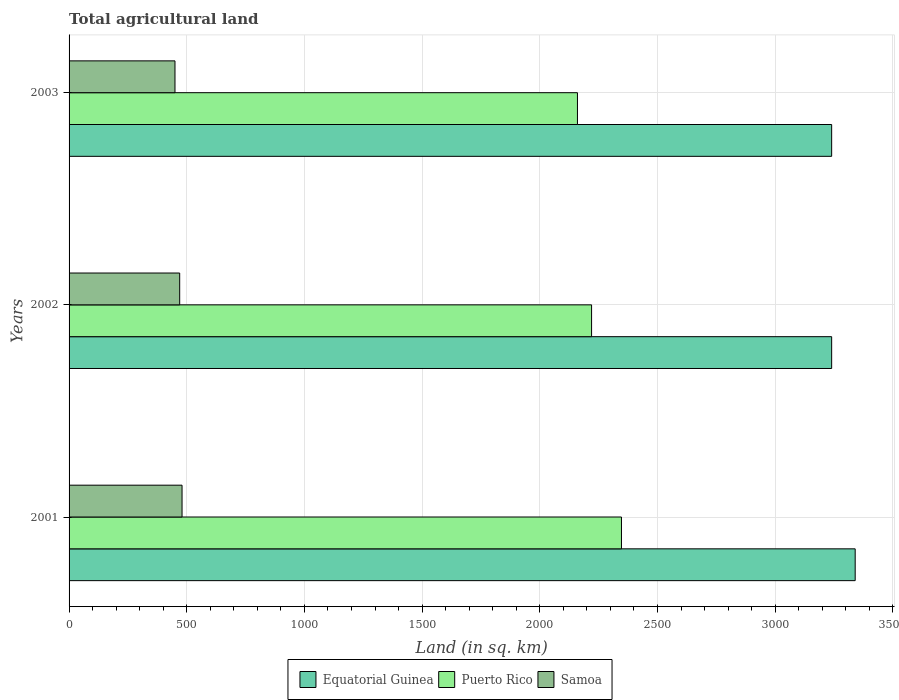How many different coloured bars are there?
Your response must be concise. 3. How many bars are there on the 1st tick from the bottom?
Your answer should be very brief. 3. What is the label of the 2nd group of bars from the top?
Ensure brevity in your answer.  2002. What is the total agricultural land in Equatorial Guinea in 2003?
Provide a succinct answer. 3240. Across all years, what is the maximum total agricultural land in Equatorial Guinea?
Your answer should be compact. 3340. Across all years, what is the minimum total agricultural land in Puerto Rico?
Offer a terse response. 2160. What is the total total agricultural land in Equatorial Guinea in the graph?
Offer a terse response. 9820. What is the difference between the total agricultural land in Puerto Rico in 2001 and that in 2003?
Give a very brief answer. 187. What is the difference between the total agricultural land in Samoa in 2003 and the total agricultural land in Equatorial Guinea in 2002?
Offer a terse response. -2790. What is the average total agricultural land in Puerto Rico per year?
Provide a short and direct response. 2242.33. In the year 2002, what is the difference between the total agricultural land in Equatorial Guinea and total agricultural land in Samoa?
Your answer should be very brief. 2770. In how many years, is the total agricultural land in Equatorial Guinea greater than 800 sq.km?
Keep it short and to the point. 3. What is the ratio of the total agricultural land in Equatorial Guinea in 2002 to that in 2003?
Offer a terse response. 1. Is the total agricultural land in Equatorial Guinea in 2001 less than that in 2003?
Offer a very short reply. No. What is the difference between the highest and the lowest total agricultural land in Puerto Rico?
Offer a terse response. 187. In how many years, is the total agricultural land in Puerto Rico greater than the average total agricultural land in Puerto Rico taken over all years?
Keep it short and to the point. 1. Is the sum of the total agricultural land in Equatorial Guinea in 2001 and 2002 greater than the maximum total agricultural land in Samoa across all years?
Provide a short and direct response. Yes. What does the 2nd bar from the top in 2002 represents?
Provide a short and direct response. Puerto Rico. What does the 3rd bar from the bottom in 2002 represents?
Provide a succinct answer. Samoa. Is it the case that in every year, the sum of the total agricultural land in Equatorial Guinea and total agricultural land in Puerto Rico is greater than the total agricultural land in Samoa?
Your response must be concise. Yes. Are all the bars in the graph horizontal?
Offer a terse response. Yes. How many years are there in the graph?
Your response must be concise. 3. Does the graph contain any zero values?
Give a very brief answer. No. Where does the legend appear in the graph?
Ensure brevity in your answer.  Bottom center. How many legend labels are there?
Offer a terse response. 3. How are the legend labels stacked?
Your answer should be compact. Horizontal. What is the title of the graph?
Keep it short and to the point. Total agricultural land. What is the label or title of the X-axis?
Your answer should be very brief. Land (in sq. km). What is the Land (in sq. km) of Equatorial Guinea in 2001?
Your answer should be compact. 3340. What is the Land (in sq. km) in Puerto Rico in 2001?
Your answer should be compact. 2347. What is the Land (in sq. km) of Samoa in 2001?
Your response must be concise. 480. What is the Land (in sq. km) in Equatorial Guinea in 2002?
Your answer should be compact. 3240. What is the Land (in sq. km) in Puerto Rico in 2002?
Offer a terse response. 2220. What is the Land (in sq. km) of Samoa in 2002?
Offer a very short reply. 470. What is the Land (in sq. km) of Equatorial Guinea in 2003?
Make the answer very short. 3240. What is the Land (in sq. km) of Puerto Rico in 2003?
Your answer should be compact. 2160. What is the Land (in sq. km) in Samoa in 2003?
Your answer should be very brief. 450. Across all years, what is the maximum Land (in sq. km) in Equatorial Guinea?
Offer a terse response. 3340. Across all years, what is the maximum Land (in sq. km) in Puerto Rico?
Your answer should be very brief. 2347. Across all years, what is the maximum Land (in sq. km) in Samoa?
Provide a succinct answer. 480. Across all years, what is the minimum Land (in sq. km) in Equatorial Guinea?
Make the answer very short. 3240. Across all years, what is the minimum Land (in sq. km) in Puerto Rico?
Make the answer very short. 2160. Across all years, what is the minimum Land (in sq. km) in Samoa?
Make the answer very short. 450. What is the total Land (in sq. km) of Equatorial Guinea in the graph?
Offer a very short reply. 9820. What is the total Land (in sq. km) of Puerto Rico in the graph?
Ensure brevity in your answer.  6727. What is the total Land (in sq. km) in Samoa in the graph?
Provide a short and direct response. 1400. What is the difference between the Land (in sq. km) of Puerto Rico in 2001 and that in 2002?
Make the answer very short. 127. What is the difference between the Land (in sq. km) in Puerto Rico in 2001 and that in 2003?
Ensure brevity in your answer.  187. What is the difference between the Land (in sq. km) of Samoa in 2001 and that in 2003?
Offer a very short reply. 30. What is the difference between the Land (in sq. km) of Equatorial Guinea in 2001 and the Land (in sq. km) of Puerto Rico in 2002?
Provide a succinct answer. 1120. What is the difference between the Land (in sq. km) of Equatorial Guinea in 2001 and the Land (in sq. km) of Samoa in 2002?
Your response must be concise. 2870. What is the difference between the Land (in sq. km) in Puerto Rico in 2001 and the Land (in sq. km) in Samoa in 2002?
Ensure brevity in your answer.  1877. What is the difference between the Land (in sq. km) of Equatorial Guinea in 2001 and the Land (in sq. km) of Puerto Rico in 2003?
Your response must be concise. 1180. What is the difference between the Land (in sq. km) in Equatorial Guinea in 2001 and the Land (in sq. km) in Samoa in 2003?
Ensure brevity in your answer.  2890. What is the difference between the Land (in sq. km) of Puerto Rico in 2001 and the Land (in sq. km) of Samoa in 2003?
Give a very brief answer. 1897. What is the difference between the Land (in sq. km) in Equatorial Guinea in 2002 and the Land (in sq. km) in Puerto Rico in 2003?
Your response must be concise. 1080. What is the difference between the Land (in sq. km) in Equatorial Guinea in 2002 and the Land (in sq. km) in Samoa in 2003?
Ensure brevity in your answer.  2790. What is the difference between the Land (in sq. km) of Puerto Rico in 2002 and the Land (in sq. km) of Samoa in 2003?
Keep it short and to the point. 1770. What is the average Land (in sq. km) in Equatorial Guinea per year?
Keep it short and to the point. 3273.33. What is the average Land (in sq. km) of Puerto Rico per year?
Give a very brief answer. 2242.33. What is the average Land (in sq. km) in Samoa per year?
Offer a very short reply. 466.67. In the year 2001, what is the difference between the Land (in sq. km) in Equatorial Guinea and Land (in sq. km) in Puerto Rico?
Offer a very short reply. 993. In the year 2001, what is the difference between the Land (in sq. km) in Equatorial Guinea and Land (in sq. km) in Samoa?
Offer a terse response. 2860. In the year 2001, what is the difference between the Land (in sq. km) in Puerto Rico and Land (in sq. km) in Samoa?
Provide a succinct answer. 1867. In the year 2002, what is the difference between the Land (in sq. km) in Equatorial Guinea and Land (in sq. km) in Puerto Rico?
Your response must be concise. 1020. In the year 2002, what is the difference between the Land (in sq. km) of Equatorial Guinea and Land (in sq. km) of Samoa?
Provide a short and direct response. 2770. In the year 2002, what is the difference between the Land (in sq. km) of Puerto Rico and Land (in sq. km) of Samoa?
Give a very brief answer. 1750. In the year 2003, what is the difference between the Land (in sq. km) of Equatorial Guinea and Land (in sq. km) of Puerto Rico?
Keep it short and to the point. 1080. In the year 2003, what is the difference between the Land (in sq. km) of Equatorial Guinea and Land (in sq. km) of Samoa?
Your answer should be compact. 2790. In the year 2003, what is the difference between the Land (in sq. km) in Puerto Rico and Land (in sq. km) in Samoa?
Ensure brevity in your answer.  1710. What is the ratio of the Land (in sq. km) in Equatorial Guinea in 2001 to that in 2002?
Ensure brevity in your answer.  1.03. What is the ratio of the Land (in sq. km) in Puerto Rico in 2001 to that in 2002?
Keep it short and to the point. 1.06. What is the ratio of the Land (in sq. km) in Samoa in 2001 to that in 2002?
Give a very brief answer. 1.02. What is the ratio of the Land (in sq. km) of Equatorial Guinea in 2001 to that in 2003?
Offer a terse response. 1.03. What is the ratio of the Land (in sq. km) in Puerto Rico in 2001 to that in 2003?
Offer a terse response. 1.09. What is the ratio of the Land (in sq. km) in Samoa in 2001 to that in 2003?
Give a very brief answer. 1.07. What is the ratio of the Land (in sq. km) of Puerto Rico in 2002 to that in 2003?
Provide a succinct answer. 1.03. What is the ratio of the Land (in sq. km) of Samoa in 2002 to that in 2003?
Offer a terse response. 1.04. What is the difference between the highest and the second highest Land (in sq. km) of Equatorial Guinea?
Your answer should be very brief. 100. What is the difference between the highest and the second highest Land (in sq. km) of Puerto Rico?
Keep it short and to the point. 127. What is the difference between the highest and the lowest Land (in sq. km) of Equatorial Guinea?
Your answer should be compact. 100. What is the difference between the highest and the lowest Land (in sq. km) of Puerto Rico?
Give a very brief answer. 187. 